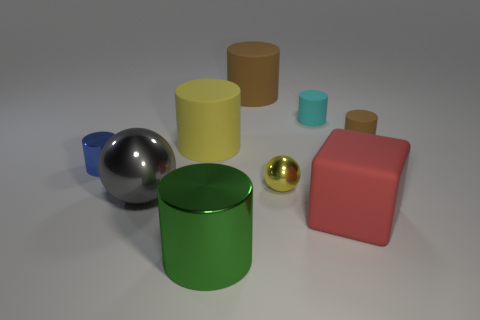Subtract all red balls. How many brown cylinders are left? 2 Subtract all cyan cylinders. How many cylinders are left? 5 Subtract all brown cylinders. How many cylinders are left? 4 Add 1 brown cylinders. How many objects exist? 10 Subtract all green cylinders. Subtract all green blocks. How many cylinders are left? 5 Subtract all balls. How many objects are left? 7 Subtract 0 red balls. How many objects are left? 9 Subtract all gray spheres. Subtract all gray metallic spheres. How many objects are left? 7 Add 5 large red things. How many large red things are left? 6 Add 3 big cyan matte spheres. How many big cyan matte spheres exist? 3 